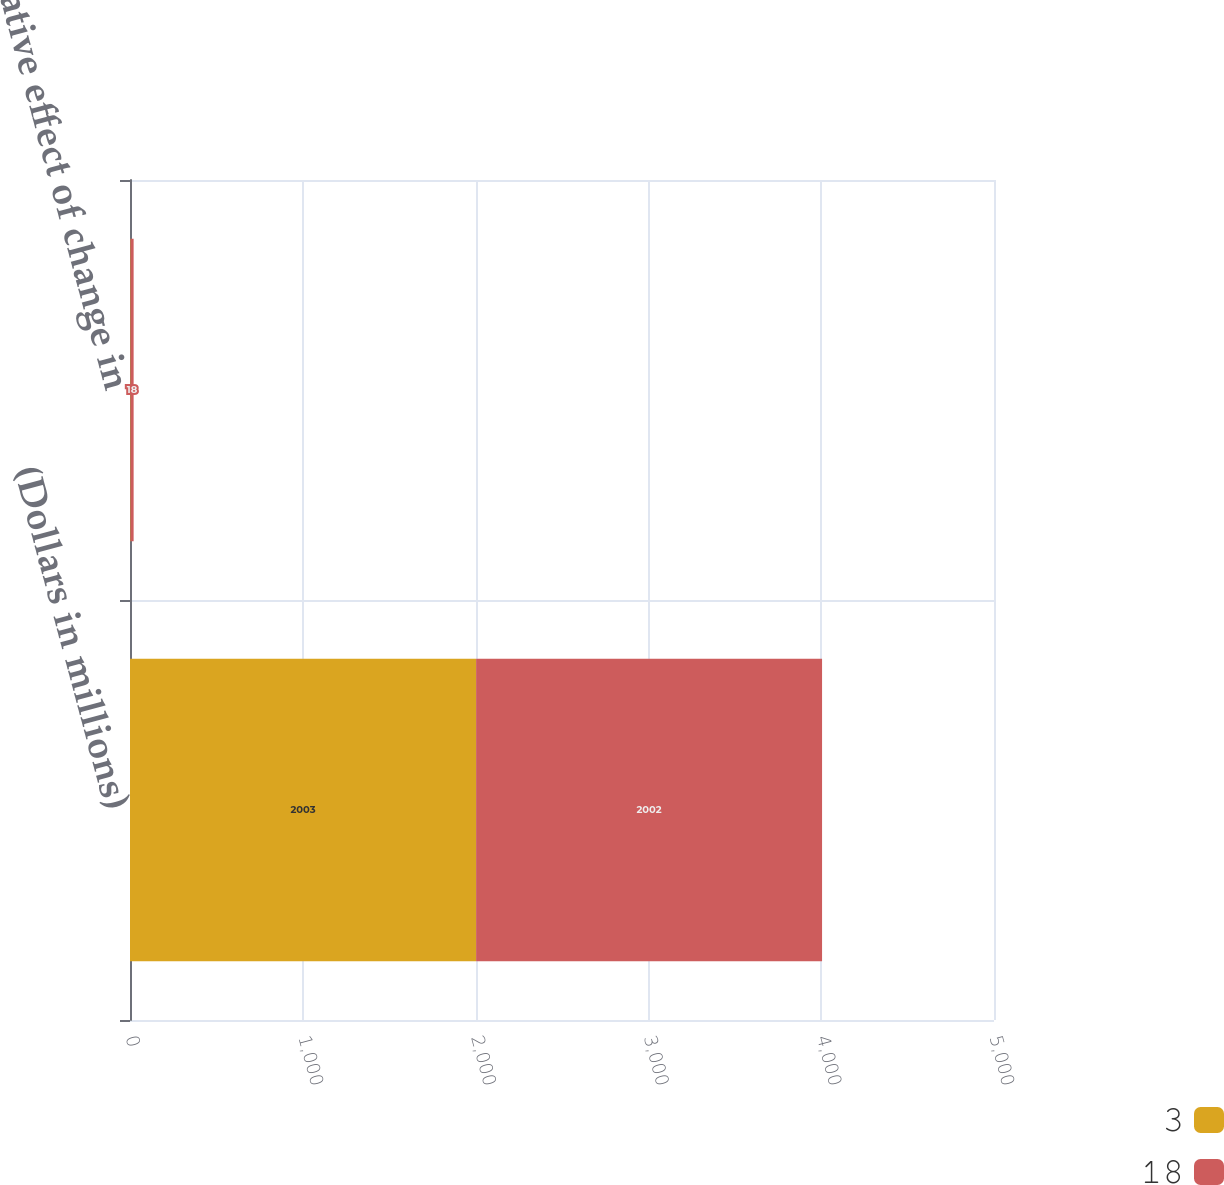<chart> <loc_0><loc_0><loc_500><loc_500><stacked_bar_chart><ecel><fcel>(Dollars in millions)<fcel>Cumulative effect of change in<nl><fcel>3<fcel>2003<fcel>3<nl><fcel>18<fcel>2002<fcel>18<nl></chart> 